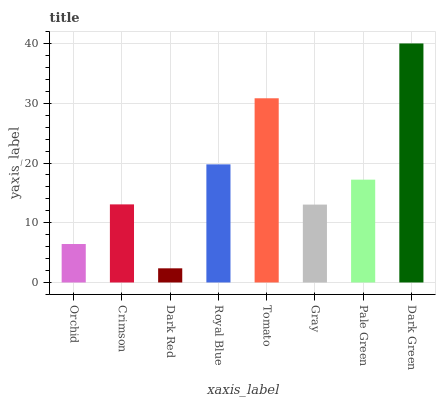Is Dark Red the minimum?
Answer yes or no. Yes. Is Dark Green the maximum?
Answer yes or no. Yes. Is Crimson the minimum?
Answer yes or no. No. Is Crimson the maximum?
Answer yes or no. No. Is Crimson greater than Orchid?
Answer yes or no. Yes. Is Orchid less than Crimson?
Answer yes or no. Yes. Is Orchid greater than Crimson?
Answer yes or no. No. Is Crimson less than Orchid?
Answer yes or no. No. Is Pale Green the high median?
Answer yes or no. Yes. Is Crimson the low median?
Answer yes or no. Yes. Is Gray the high median?
Answer yes or no. No. Is Gray the low median?
Answer yes or no. No. 